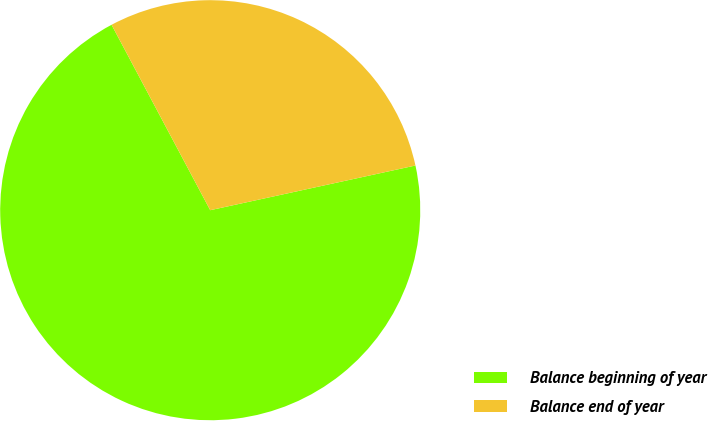Convert chart to OTSL. <chart><loc_0><loc_0><loc_500><loc_500><pie_chart><fcel>Balance beginning of year<fcel>Balance end of year<nl><fcel>70.63%<fcel>29.37%<nl></chart> 